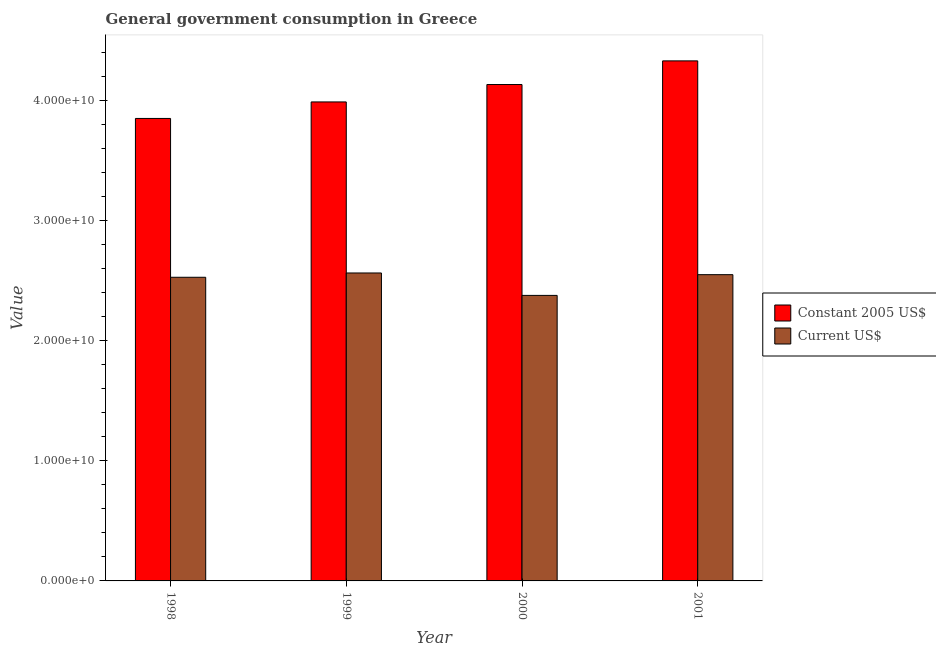How many different coloured bars are there?
Keep it short and to the point. 2. How many groups of bars are there?
Your response must be concise. 4. Are the number of bars on each tick of the X-axis equal?
Give a very brief answer. Yes. How many bars are there on the 2nd tick from the left?
Provide a short and direct response. 2. How many bars are there on the 3rd tick from the right?
Give a very brief answer. 2. In how many cases, is the number of bars for a given year not equal to the number of legend labels?
Provide a succinct answer. 0. What is the value consumed in current us$ in 1998?
Your response must be concise. 2.53e+1. Across all years, what is the maximum value consumed in constant 2005 us$?
Your answer should be compact. 4.33e+1. Across all years, what is the minimum value consumed in constant 2005 us$?
Your answer should be very brief. 3.85e+1. In which year was the value consumed in current us$ minimum?
Keep it short and to the point. 2000. What is the total value consumed in current us$ in the graph?
Your answer should be compact. 1.00e+11. What is the difference between the value consumed in constant 2005 us$ in 1999 and that in 2000?
Make the answer very short. -1.45e+09. What is the difference between the value consumed in current us$ in 1999 and the value consumed in constant 2005 us$ in 1998?
Ensure brevity in your answer.  3.58e+08. What is the average value consumed in constant 2005 us$ per year?
Your response must be concise. 4.07e+1. In the year 1999, what is the difference between the value consumed in current us$ and value consumed in constant 2005 us$?
Ensure brevity in your answer.  0. In how many years, is the value consumed in constant 2005 us$ greater than 12000000000?
Make the answer very short. 4. What is the ratio of the value consumed in current us$ in 1998 to that in 1999?
Offer a very short reply. 0.99. Is the value consumed in constant 2005 us$ in 1999 less than that in 2001?
Provide a short and direct response. Yes. Is the difference between the value consumed in current us$ in 1998 and 2000 greater than the difference between the value consumed in constant 2005 us$ in 1998 and 2000?
Give a very brief answer. No. What is the difference between the highest and the second highest value consumed in current us$?
Ensure brevity in your answer.  1.41e+08. What is the difference between the highest and the lowest value consumed in current us$?
Your response must be concise. 1.87e+09. Is the sum of the value consumed in current us$ in 1998 and 1999 greater than the maximum value consumed in constant 2005 us$ across all years?
Provide a succinct answer. Yes. What does the 1st bar from the left in 2000 represents?
Ensure brevity in your answer.  Constant 2005 US$. What does the 1st bar from the right in 1999 represents?
Your answer should be compact. Current US$. How many bars are there?
Ensure brevity in your answer.  8. Are all the bars in the graph horizontal?
Keep it short and to the point. No. What is the difference between two consecutive major ticks on the Y-axis?
Keep it short and to the point. 1.00e+1. Are the values on the major ticks of Y-axis written in scientific E-notation?
Make the answer very short. Yes. Does the graph contain any zero values?
Your response must be concise. No. Does the graph contain grids?
Your response must be concise. No. Where does the legend appear in the graph?
Offer a terse response. Center right. How many legend labels are there?
Provide a succinct answer. 2. What is the title of the graph?
Give a very brief answer. General government consumption in Greece. Does "Birth rate" appear as one of the legend labels in the graph?
Provide a succinct answer. No. What is the label or title of the X-axis?
Ensure brevity in your answer.  Year. What is the label or title of the Y-axis?
Offer a very short reply. Value. What is the Value of Constant 2005 US$ in 1998?
Provide a succinct answer. 3.85e+1. What is the Value of Current US$ in 1998?
Keep it short and to the point. 2.53e+1. What is the Value of Constant 2005 US$ in 1999?
Your answer should be compact. 3.99e+1. What is the Value in Current US$ in 1999?
Offer a terse response. 2.56e+1. What is the Value of Constant 2005 US$ in 2000?
Provide a succinct answer. 4.13e+1. What is the Value in Current US$ in 2000?
Provide a short and direct response. 2.38e+1. What is the Value in Constant 2005 US$ in 2001?
Your response must be concise. 4.33e+1. What is the Value of Current US$ in 2001?
Your answer should be very brief. 2.55e+1. Across all years, what is the maximum Value in Constant 2005 US$?
Offer a terse response. 4.33e+1. Across all years, what is the maximum Value of Current US$?
Your response must be concise. 2.56e+1. Across all years, what is the minimum Value in Constant 2005 US$?
Give a very brief answer. 3.85e+1. Across all years, what is the minimum Value of Current US$?
Make the answer very short. 2.38e+1. What is the total Value in Constant 2005 US$ in the graph?
Offer a very short reply. 1.63e+11. What is the total Value of Current US$ in the graph?
Provide a short and direct response. 1.00e+11. What is the difference between the Value in Constant 2005 US$ in 1998 and that in 1999?
Offer a terse response. -1.37e+09. What is the difference between the Value in Current US$ in 1998 and that in 1999?
Offer a terse response. -3.58e+08. What is the difference between the Value in Constant 2005 US$ in 1998 and that in 2000?
Your response must be concise. -2.82e+09. What is the difference between the Value of Current US$ in 1998 and that in 2000?
Your answer should be very brief. 1.51e+09. What is the difference between the Value of Constant 2005 US$ in 1998 and that in 2001?
Offer a terse response. -4.79e+09. What is the difference between the Value of Current US$ in 1998 and that in 2001?
Ensure brevity in your answer.  -2.17e+08. What is the difference between the Value in Constant 2005 US$ in 1999 and that in 2000?
Give a very brief answer. -1.45e+09. What is the difference between the Value of Current US$ in 1999 and that in 2000?
Give a very brief answer. 1.87e+09. What is the difference between the Value of Constant 2005 US$ in 1999 and that in 2001?
Offer a terse response. -3.42e+09. What is the difference between the Value of Current US$ in 1999 and that in 2001?
Your response must be concise. 1.41e+08. What is the difference between the Value of Constant 2005 US$ in 2000 and that in 2001?
Provide a succinct answer. -1.97e+09. What is the difference between the Value in Current US$ in 2000 and that in 2001?
Keep it short and to the point. -1.73e+09. What is the difference between the Value in Constant 2005 US$ in 1998 and the Value in Current US$ in 1999?
Provide a succinct answer. 1.29e+1. What is the difference between the Value in Constant 2005 US$ in 1998 and the Value in Current US$ in 2000?
Offer a terse response. 1.47e+1. What is the difference between the Value of Constant 2005 US$ in 1998 and the Value of Current US$ in 2001?
Give a very brief answer. 1.30e+1. What is the difference between the Value in Constant 2005 US$ in 1999 and the Value in Current US$ in 2000?
Your answer should be compact. 1.61e+1. What is the difference between the Value of Constant 2005 US$ in 1999 and the Value of Current US$ in 2001?
Provide a succinct answer. 1.44e+1. What is the difference between the Value of Constant 2005 US$ in 2000 and the Value of Current US$ in 2001?
Ensure brevity in your answer.  1.58e+1. What is the average Value in Constant 2005 US$ per year?
Your answer should be very brief. 4.07e+1. What is the average Value of Current US$ per year?
Give a very brief answer. 2.50e+1. In the year 1998, what is the difference between the Value of Constant 2005 US$ and Value of Current US$?
Provide a short and direct response. 1.32e+1. In the year 1999, what is the difference between the Value in Constant 2005 US$ and Value in Current US$?
Keep it short and to the point. 1.42e+1. In the year 2000, what is the difference between the Value in Constant 2005 US$ and Value in Current US$?
Give a very brief answer. 1.75e+1. In the year 2001, what is the difference between the Value in Constant 2005 US$ and Value in Current US$?
Offer a terse response. 1.78e+1. What is the ratio of the Value in Constant 2005 US$ in 1998 to that in 1999?
Offer a terse response. 0.97. What is the ratio of the Value in Current US$ in 1998 to that in 1999?
Offer a very short reply. 0.99. What is the ratio of the Value in Constant 2005 US$ in 1998 to that in 2000?
Provide a succinct answer. 0.93. What is the ratio of the Value in Current US$ in 1998 to that in 2000?
Your answer should be compact. 1.06. What is the ratio of the Value in Constant 2005 US$ in 1998 to that in 2001?
Provide a short and direct response. 0.89. What is the ratio of the Value in Current US$ in 1998 to that in 2001?
Provide a succinct answer. 0.99. What is the ratio of the Value of Constant 2005 US$ in 1999 to that in 2000?
Your response must be concise. 0.96. What is the ratio of the Value in Current US$ in 1999 to that in 2000?
Your answer should be compact. 1.08. What is the ratio of the Value of Constant 2005 US$ in 1999 to that in 2001?
Offer a very short reply. 0.92. What is the ratio of the Value of Current US$ in 1999 to that in 2001?
Offer a terse response. 1.01. What is the ratio of the Value of Constant 2005 US$ in 2000 to that in 2001?
Make the answer very short. 0.95. What is the ratio of the Value in Current US$ in 2000 to that in 2001?
Your answer should be very brief. 0.93. What is the difference between the highest and the second highest Value of Constant 2005 US$?
Keep it short and to the point. 1.97e+09. What is the difference between the highest and the second highest Value of Current US$?
Make the answer very short. 1.41e+08. What is the difference between the highest and the lowest Value of Constant 2005 US$?
Keep it short and to the point. 4.79e+09. What is the difference between the highest and the lowest Value of Current US$?
Your answer should be very brief. 1.87e+09. 